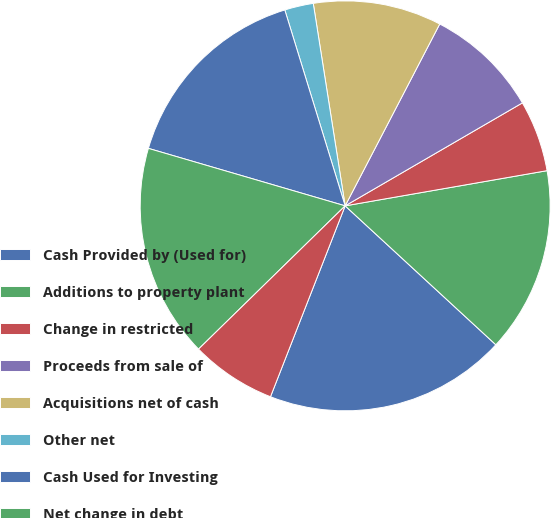Convert chart. <chart><loc_0><loc_0><loc_500><loc_500><pie_chart><fcel>Cash Provided by (Used for)<fcel>Additions to property plant<fcel>Change in restricted<fcel>Proceeds from sale of<fcel>Acquisitions net of cash<fcel>Other net<fcel>Cash Used for Investing<fcel>Net change in debt<fcel>Debt issuance costs<nl><fcel>19.08%<fcel>14.6%<fcel>5.63%<fcel>8.99%<fcel>10.12%<fcel>2.27%<fcel>15.72%<fcel>16.84%<fcel>6.75%<nl></chart> 